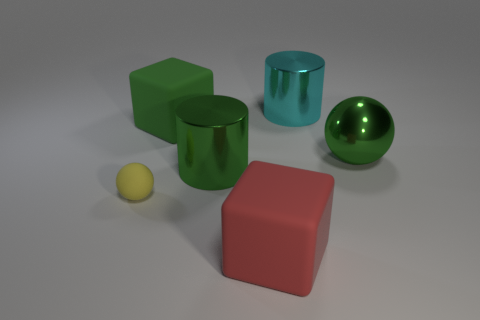There is a big green object that is right of the big cyan object that is behind the green ball that is in front of the large green rubber block; what shape is it?
Provide a succinct answer. Sphere. What number of big spheres are on the left side of the red thing?
Offer a very short reply. 0. Do the big green thing to the left of the green metallic cylinder and the red thing have the same material?
Your answer should be compact. Yes. How many other things are the same shape as the green rubber thing?
Give a very brief answer. 1. There is a matte object that is behind the yellow sphere that is in front of the large green matte thing; what number of blocks are to the right of it?
Your answer should be very brief. 1. The metallic object that is behind the metallic ball is what color?
Your answer should be very brief. Cyan. There is a big object that is on the left side of the green metallic cylinder; is its color the same as the metallic sphere?
Your answer should be very brief. Yes. Are there any other things that are the same size as the yellow rubber ball?
Provide a short and direct response. No. There is a large cube that is right of the large green matte object on the left side of the metallic cylinder that is behind the large green shiny ball; what is it made of?
Your answer should be compact. Rubber. Are there more things in front of the large green ball than big cyan things in front of the rubber ball?
Your answer should be very brief. Yes. 